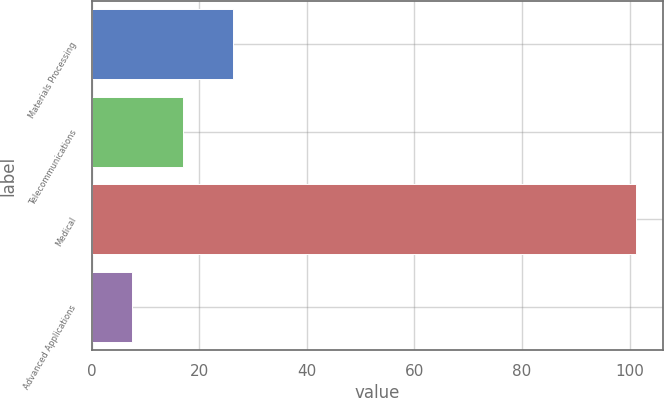<chart> <loc_0><loc_0><loc_500><loc_500><bar_chart><fcel>Materials Processing<fcel>Telecommunications<fcel>Medical<fcel>Advanced Applications<nl><fcel>26.3<fcel>16.95<fcel>101.1<fcel>7.6<nl></chart> 